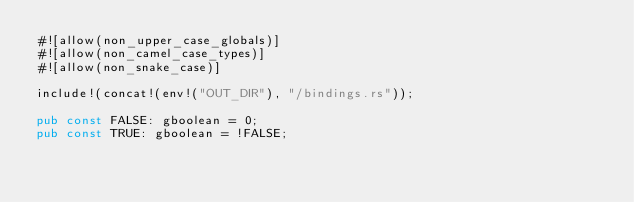<code> <loc_0><loc_0><loc_500><loc_500><_Rust_>#![allow(non_upper_case_globals)]
#![allow(non_camel_case_types)]
#![allow(non_snake_case)]

include!(concat!(env!("OUT_DIR"), "/bindings.rs"));

pub const FALSE: gboolean = 0;
pub const TRUE: gboolean = !FALSE;
</code> 